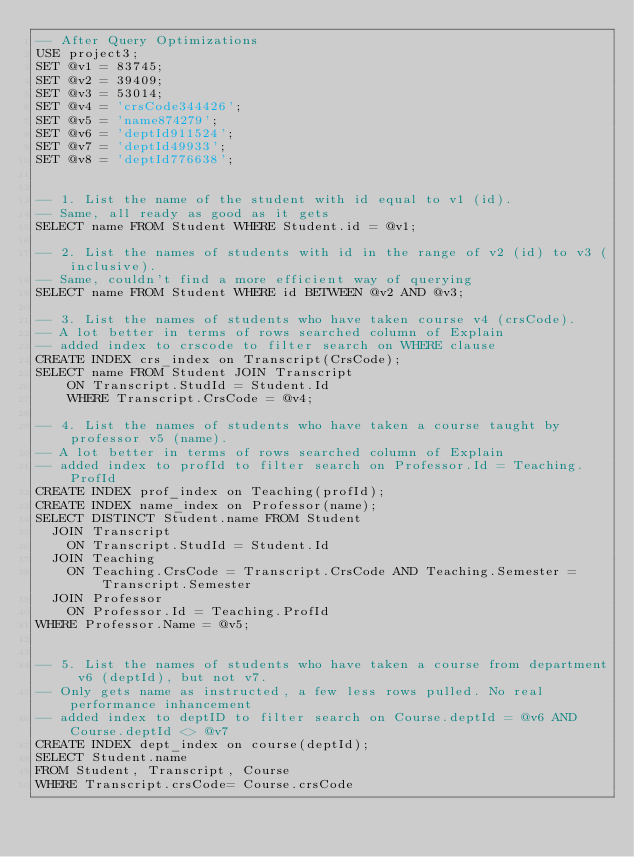Convert code to text. <code><loc_0><loc_0><loc_500><loc_500><_SQL_>-- After Query Optimizations
USE project3;
SET @v1 = 83745;
SET @v2 = 39409;
SET @v3 = 53014;
SET @v4 = 'crsCode344426';
SET @v5 = 'name874279';
SET @v6 = 'deptId911524';
SET @v7 = 'deptId49933';
SET @v8 = 'deptId776638';


-- 1. List the name of the student with id equal to v1 (id).
-- Same, all ready as good as it gets
SELECT name FROM Student WHERE Student.id = @v1;

-- 2. List the names of students with id in the range of v2 (id) to v3 (inclusive).
-- Same, couldn't find a more efficient way of querying
SELECT name FROM Student WHERE id BETWEEN @v2 AND @v3;

-- 3. List the names of students who have taken course v4 (crsCode).
-- A lot better in terms of rows searched column of Explain
-- added index to crscode to filter search on WHERE clause
CREATE INDEX crs_index on Transcript(CrsCode);
SELECT name FROM Student JOIN Transcript
		ON Transcript.StudId = Student.Id
		WHERE Transcript.CrsCode = @v4;

-- 4. List the names of students who have taken a course taught by professor v5 (name).
-- A lot better in terms of rows searched column of Explain
-- added index to profId to filter search on Professor.Id = Teaching.ProfId
CREATE INDEX prof_index on Teaching(profId);
CREATE INDEX name_index on Professor(name);
SELECT DISTINCT Student.name FROM Student
	JOIN Transcript
		ON Transcript.StudId = Student.Id
	JOIN Teaching
		ON Teaching.CrsCode = Transcript.CrsCode AND Teaching.Semester = Transcript.Semester
	JOIN Professor
		ON Professor.Id = Teaching.ProfId
WHERE Professor.Name = @v5;


-- 5. List the names of students who have taken a course from department v6 (deptId), but not v7.
-- Only gets name as instructed, a few less rows pulled. No real performance inhancement
-- added index to deptID to filter search on Course.deptId = @v6 AND Course.deptId <> @v7
CREATE INDEX dept_index on course(deptId);
SELECT Student.name
FROM Student, Transcript, Course
WHERE Transcript.crsCode= Course.crsCode</code> 